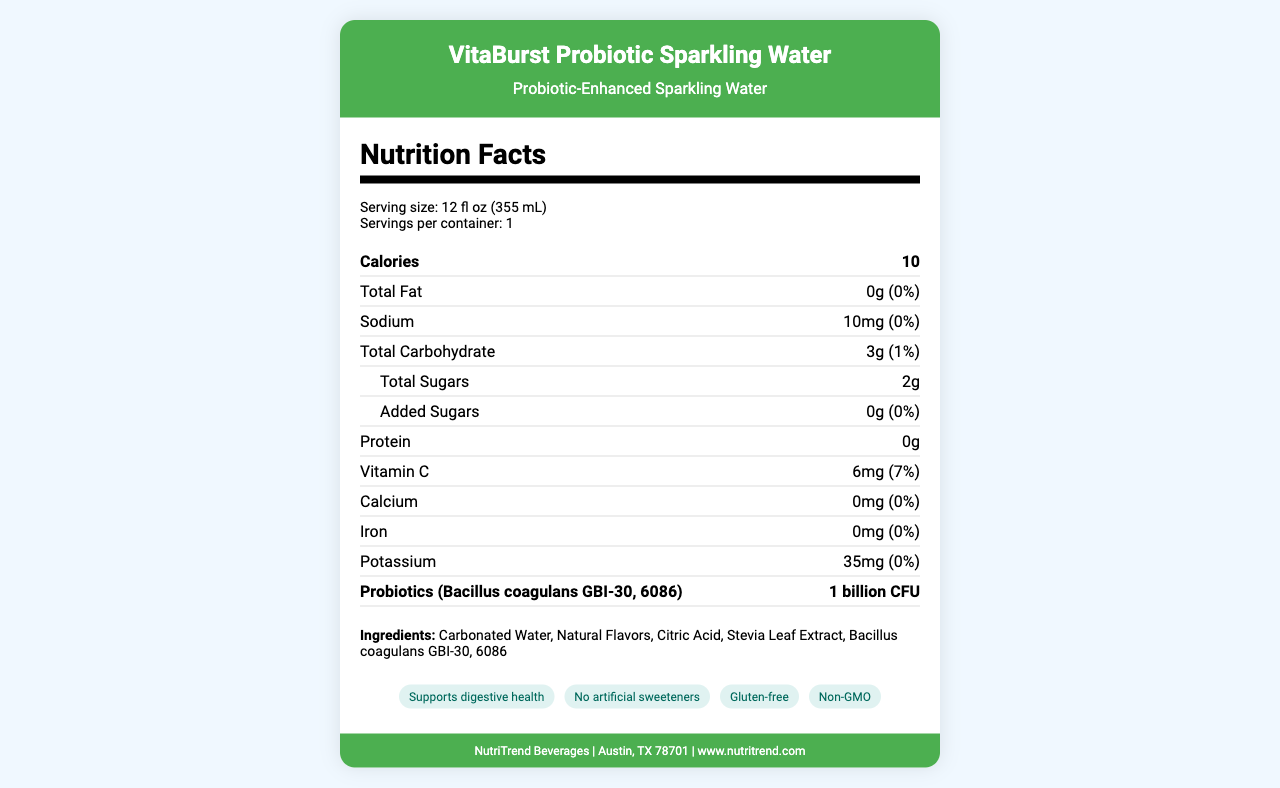what is the serving size? The serving size is listed under the serving information as 12 fl oz (355 mL).
Answer: 12 fl oz (355 mL) how many calories does a serving contain? The number of calories per serving is listed as 10.
Answer: 10 what strain of probiotics is included in this product? The probiotics strain is mentioned under the probiotics section as Bacillus coagulans GBI-30, 6086.
Answer: Bacillus coagulans GBI-30, 6086 how much sodium is there in one serving? The amount of sodium per serving is listed as 10mg.
Answer: 10mg how many grams of protein are in the product? The amount of protein in the product is listed as 0g.
Answer: 0g which of the following flavors is not available for this product? A. Lemon Lime B. Mixed Berry C. Orange Citrus D. Peach Mango The available flavors listed in the document are Lemon Lime, Mixed Berry, and Peach Mango. Orange Citrus is not listed.
Answer: C how many grams of added sugars are in one serving? The amount of added sugars per serving is listed as 0g.
Answer: 0g what is the suggested storage method after opening? A. Keep in a cool, dry place B. Refrigerate after opening C. Consume immediately D. Keep at room temperature The document advises to refrigerate after opening.
Answer: B is this product suitable for individuals following a gluten-free diet? One of the health claims mentioned in the document is that the product is gluten-free.
Answer: Yes what is the daily value percentage of Vitamin C in this product? The daily value percentage of Vitamin C is listed as 7%.
Answer: 7% how many grams of total carbohydrates are there per serving? The amount of total carbohydrates per serving is listed as 3g.
Answer: 3g is the packaging of this product recyclable? The document states that the packaging is made from 100% recyclable aluminum.
Answer: Yes describe the main idea of the document The document is focused on providing comprehensive information about VitaBurst Probiotic Sparkling Water. It includes nutritional values, ingredients, health claims, packaging, storage instructions, and company contact information. It aims to inform consumers about the product's health benefits and responsible packaging.
Answer: The document provides detailed nutritional information for VitaBurst Probiotic Sparkling Water. It highlights the key components such as calories, macronutrients, probiotics, vitamins, and minerals. It also presents the ingredients list, health claims, storage instructions, and company details. Additionally, it emphasizes the product's health benefits, such as supporting digestive health, being gluten-free, and containing no artificial sweeteners. how much calcium does the product provide per serving? The amount of calcium per serving is listed as 0mg.
Answer: 0mg can we determine the exact production date of this product based on the document? The document does not provide information about the production date of the product.
Answer: Cannot be determined are there any artificial sweeteners in this product? One of the health claims mentioned is "No artificial sweeteners," indicating the absence of artificial sweeteners in the product.
Answer: No which social media platform is not mentioned for the company? A. Instagram B. Pinterest C. Twitter D. Facebook The social media platforms mentioned are Instagram, Twitter, and Facebook. Pinterest is not mentioned.
Answer: B which ingredient provides the probiotic strain in this product? The probiotic strain Bacillus coagulans GBI-30, 6086 is specifically listed as one of the ingredients.
Answer: Bacillus coagulans GBI-30, 6086 what is the company's location? The company's location is given as Austin, TX 78701.
Answer: Austin, TX 78701 what amount of potassium does one serving contain? The amount of potassium per serving is listed as 35mg.
Answer: 35mg 